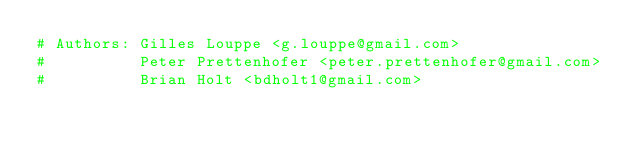Convert code to text. <code><loc_0><loc_0><loc_500><loc_500><_Cython_># Authors: Gilles Louppe <g.louppe@gmail.com>
#          Peter Prettenhofer <peter.prettenhofer@gmail.com>
#          Brian Holt <bdholt1@gmail.com></code> 